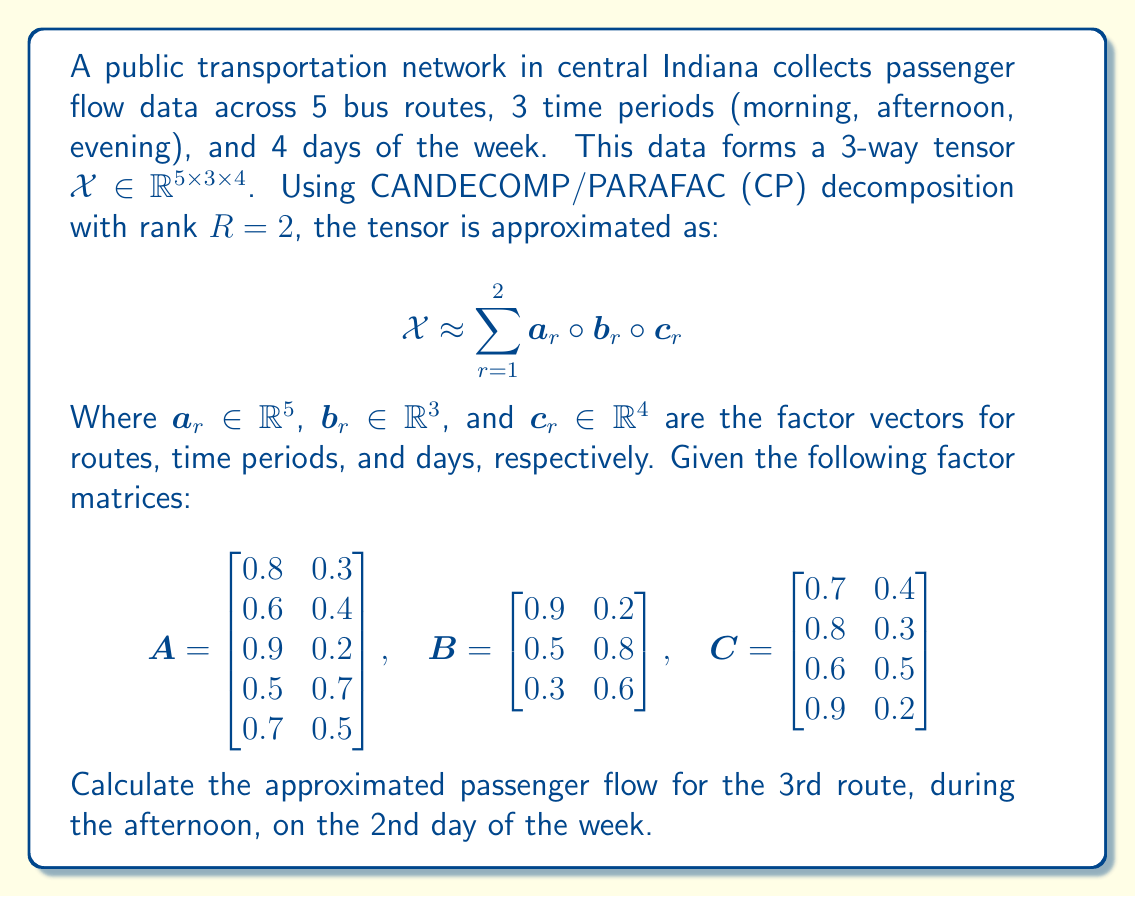Could you help me with this problem? Let's approach this step-by-step:

1) In CP decomposition, the approximated value for an element of the tensor is given by the sum of the products of the corresponding elements in the factor vectors:

   $$x_{ijk} \approx \sum_{r=1}^{R} a_{ir} b_{jr} c_{kr}$$

2) In this case, we need to calculate $x_{322}$ (3rd route, 2nd time period, 2nd day).

3) From the given factor matrices:
   - For the 3rd route: $a_{31} = 0.9$, $a_{32} = 0.2$
   - For the afternoon (2nd time period): $b_{21} = 0.5$, $b_{22} = 0.8$
   - For the 2nd day: $c_{21} = 0.8$, $c_{22} = 0.3$

4) Now, let's apply the formula:

   $$x_{322} \approx (a_{31} \cdot b_{21} \cdot c_{21}) + (a_{32} \cdot b_{22} \cdot c_{22})$$

5) Substituting the values:

   $$x_{322} \approx (0.9 \cdot 0.5 \cdot 0.8) + (0.2 \cdot 0.8 \cdot 0.3)$$

6) Calculating:

   $$x_{322} \approx 0.36 + 0.048 = 0.408$$

Therefore, the approximated passenger flow for the 3rd route, during the afternoon, on the 2nd day of the week is 0.408.
Answer: 0.408 